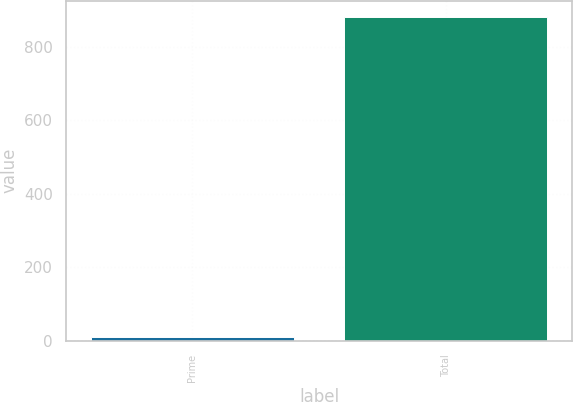<chart> <loc_0><loc_0><loc_500><loc_500><bar_chart><fcel>Prime<fcel>Total<nl><fcel>9<fcel>882<nl></chart> 